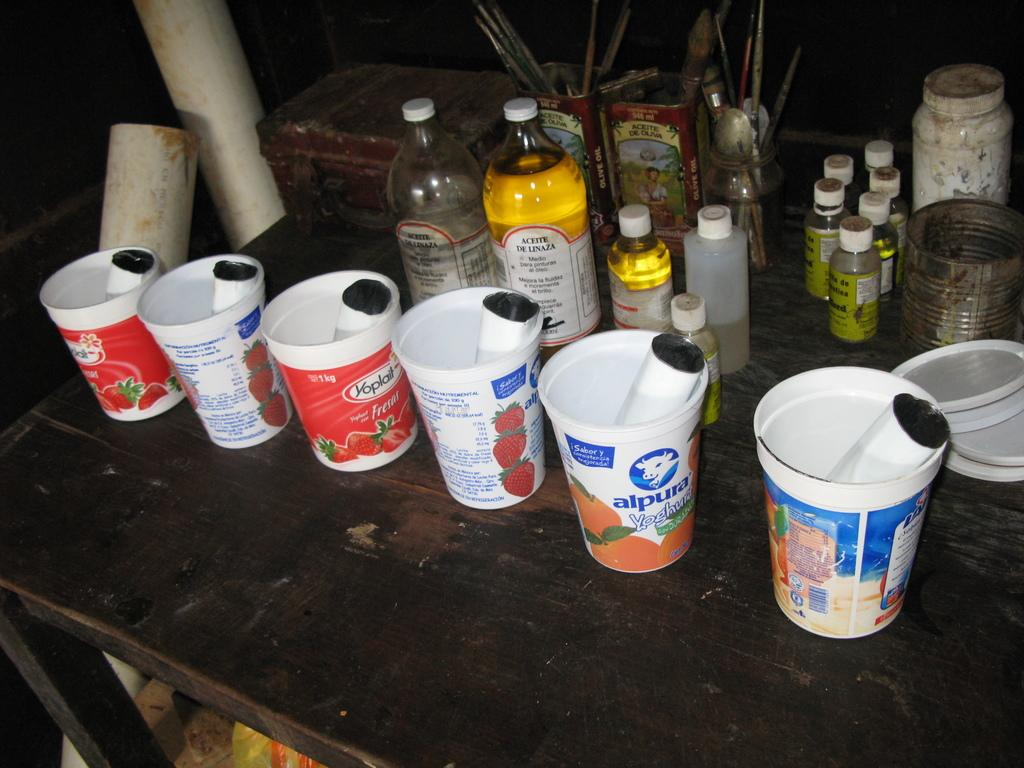What type of table is in the image? There is a wooden table in the image. What is placed on the wooden table? There is a wooden box, bottles, a jar with spoons, and plastic cups on the table. Can you describe the wooden box on the table? The wooden box is on the table. What might be used for holding or serving liquids on the table? The bottles and plastic cups on the table might be used for holding or serving liquids. How many pigs are visible on the table in the image? There are no pigs visible on the table in the image. What type of insect can be seen crawling on the wooden box? There are no insects present in the image. 